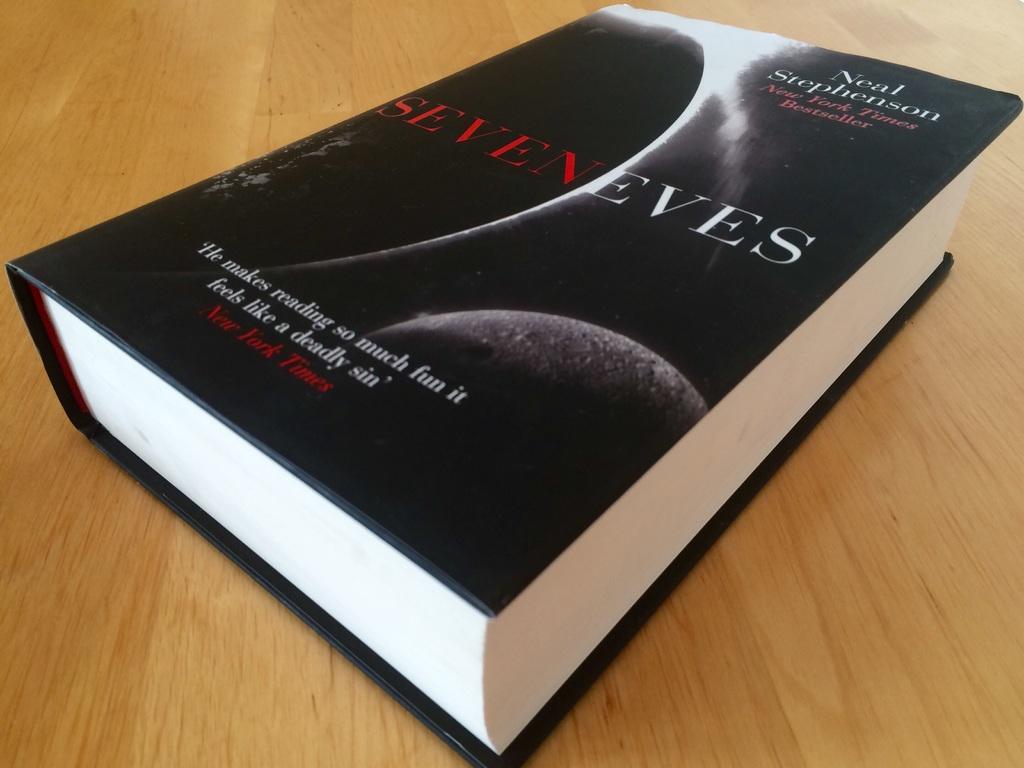What is the title of the book?
Your answer should be compact. Seven eves. 